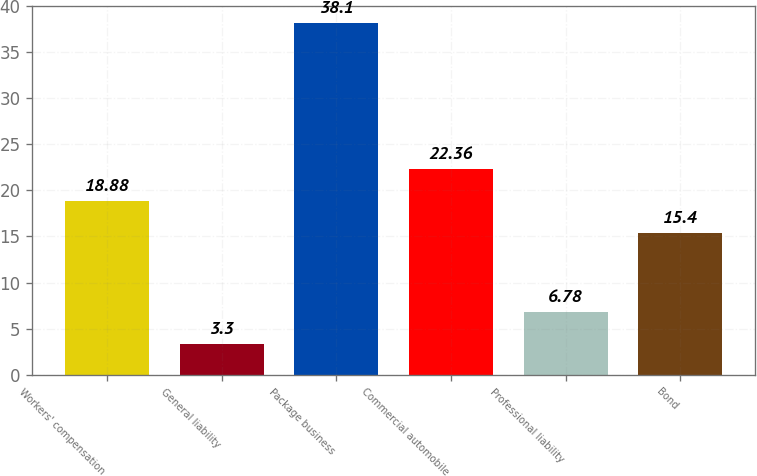<chart> <loc_0><loc_0><loc_500><loc_500><bar_chart><fcel>Workers' compensation<fcel>General liability<fcel>Package business<fcel>Commercial automobile<fcel>Professional liability<fcel>Bond<nl><fcel>18.88<fcel>3.3<fcel>38.1<fcel>22.36<fcel>6.78<fcel>15.4<nl></chart> 